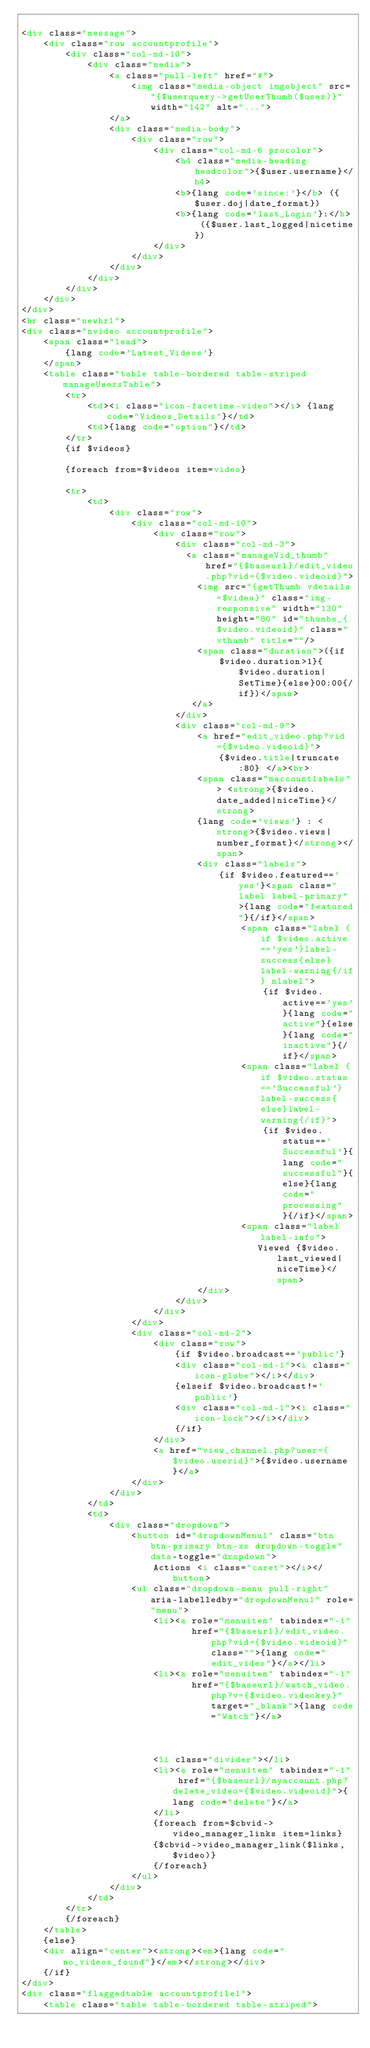<code> <loc_0><loc_0><loc_500><loc_500><_HTML_>
<div class="message">
	<div class="row accountprofile">
		<div class="col-md-10">
			<div class="media">
				<a class="pull-left" href="#">
					<img class="media-object imgobject" src="{$userquery->getUserThumb($user)}" width="142" alt="...">
				</a>
				<div class="media-body">
					<div class="row">
						<div class="col-md-6 procolor">
							<h4 class="media-heading headcolor">{$user.username}</h4>
							<b>{lang code='since:'}</b> ({$user.doj|date_format})
							<b>{lang code='last_Login'}:</b> ({$user.last_logged|nicetime})
						</div>
					</div>
				</div>
			</div>
		</div>
	</div>
</div>
<hr class="newhr1">
<div class="mvideo accountprofile">
	<span class="lead">
		{lang code='Latest_Videos'}
	</span>
	<table class="table table-bordered table-striped manageUsersTable">
		<tr>
			<td><i class="icon-facetime-video"></i> {lang code="Videos_Details"}</td>
			<td>{lang code="option"}</td>
		</tr>
		{if $videos}
		
		{foreach from=$videos item=video}

		<tr>
			<td>
				<div class="row">
					<div class="col-md-10">
						<div class="row">
							<div class="col-md-3">
							  <a class="manageVid_thumb" href="{$baseurl}/edit_video.php?vid={$video.videoid}">
								<img src="{getThumb vdetails=$video}" class="img-responsive" width="130" height="80" id="thumbs_{$video.videoid}" class="vthumb" title=""/>
								<span class="duration">({if
									$video.duration>1}{$video.duration|SetTime}{else}00:00{/if})</span>
							   </a>     
							</div>
							<div class="col-md-9">
								<a href="edit_video.php?vid={$video.videoid}">
									{$video.title|truncate:80} </a><br>
								<span class="maccountlabels"> <strong>{$video.date_added|niceTime}</strong>
								{lang code='views'} : <strong>{$video.views|number_format}</strong></span>
								<div class="labels">
									{if $video.featured=='yes'}<span class="label label-primary">{lang code="featured"}{/if}</span>
										<span class="label {if $video.active=='yes'}label-success{else}label-warning{/if} mlabel">
											{if $video.active=='yes'}{lang code="active"}{else}{lang code="inactive"}{/if}</span>
										<span class="label {if $video.status=='Successful'}label-success{else}label-warning{/if}">
											{if $video.status=='Successful'}{lang code="successful"}{else}{lang code="processing"}{/if}</span>
										<span class="label label-info">
										   Viewed {$video.last_viewed|niceTime}</span>
								</div>
							</div>
						</div>
					</div>
					<div class="col-md-2">
						<div class="row">
							{if $video.broadcast=='public'}
							<div class="col-md-1"><i class="icon-globe"></i></div>
							{elseif $video.broadcast!='public'}
							<div class="col-md-1"><i class="icon-lock"></i></div>
							{/if}
						</div>
						<a href="view_channel.php?user={$video.userid}">{$video.username}</a>
					</div>
				</div>
			</td>
			<td>
				<div class="dropdown">
					<button id="dropdownMenu1" class="btn btn-primary btn-xs dropdown-toggle" data-toggle="dropdown">
						Actions <i class="caret"></i></button>
					<ul class="dropdown-menu pull-right" aria-labelledby="dropdownMenu1" role="menu">
						<li><a role="menuitem" tabindex="-1"
							   href="{$baseurl}/edit_video.php?vid={$video.videoid}" class="">{lang code="edit_video"}</a></li>
						<li><a role="menuitem" tabindex="-1"
							   href="{$baseurl}/watch_video.php?v={$video.videokey}"target="_blank">{lang code="Watch"}</a>
						 
					   
						
						<li class="divider"></li>
						<li><a role="menuitem" tabindex="-1" href="{$baseurl}/myaccount.php?delete_video={$video.videoid}">{lang code="delete"}</a>
						</li>
						{foreach from=$cbvid->video_manager_links item=links}
						{$cbvid->video_manager_link($links,$video)}
						{/foreach}
					</ul>
				</div>
			</td>
		</tr>
		{/foreach}
	</table>
	{else}
	<div align="center"><strong><em>{lang code="no_videos_found"}</em></strong></div>
	{/if}
</div>
<div class="flaggedtable accountprofile1">
	<table class="table table-bordered table-striped"></code> 